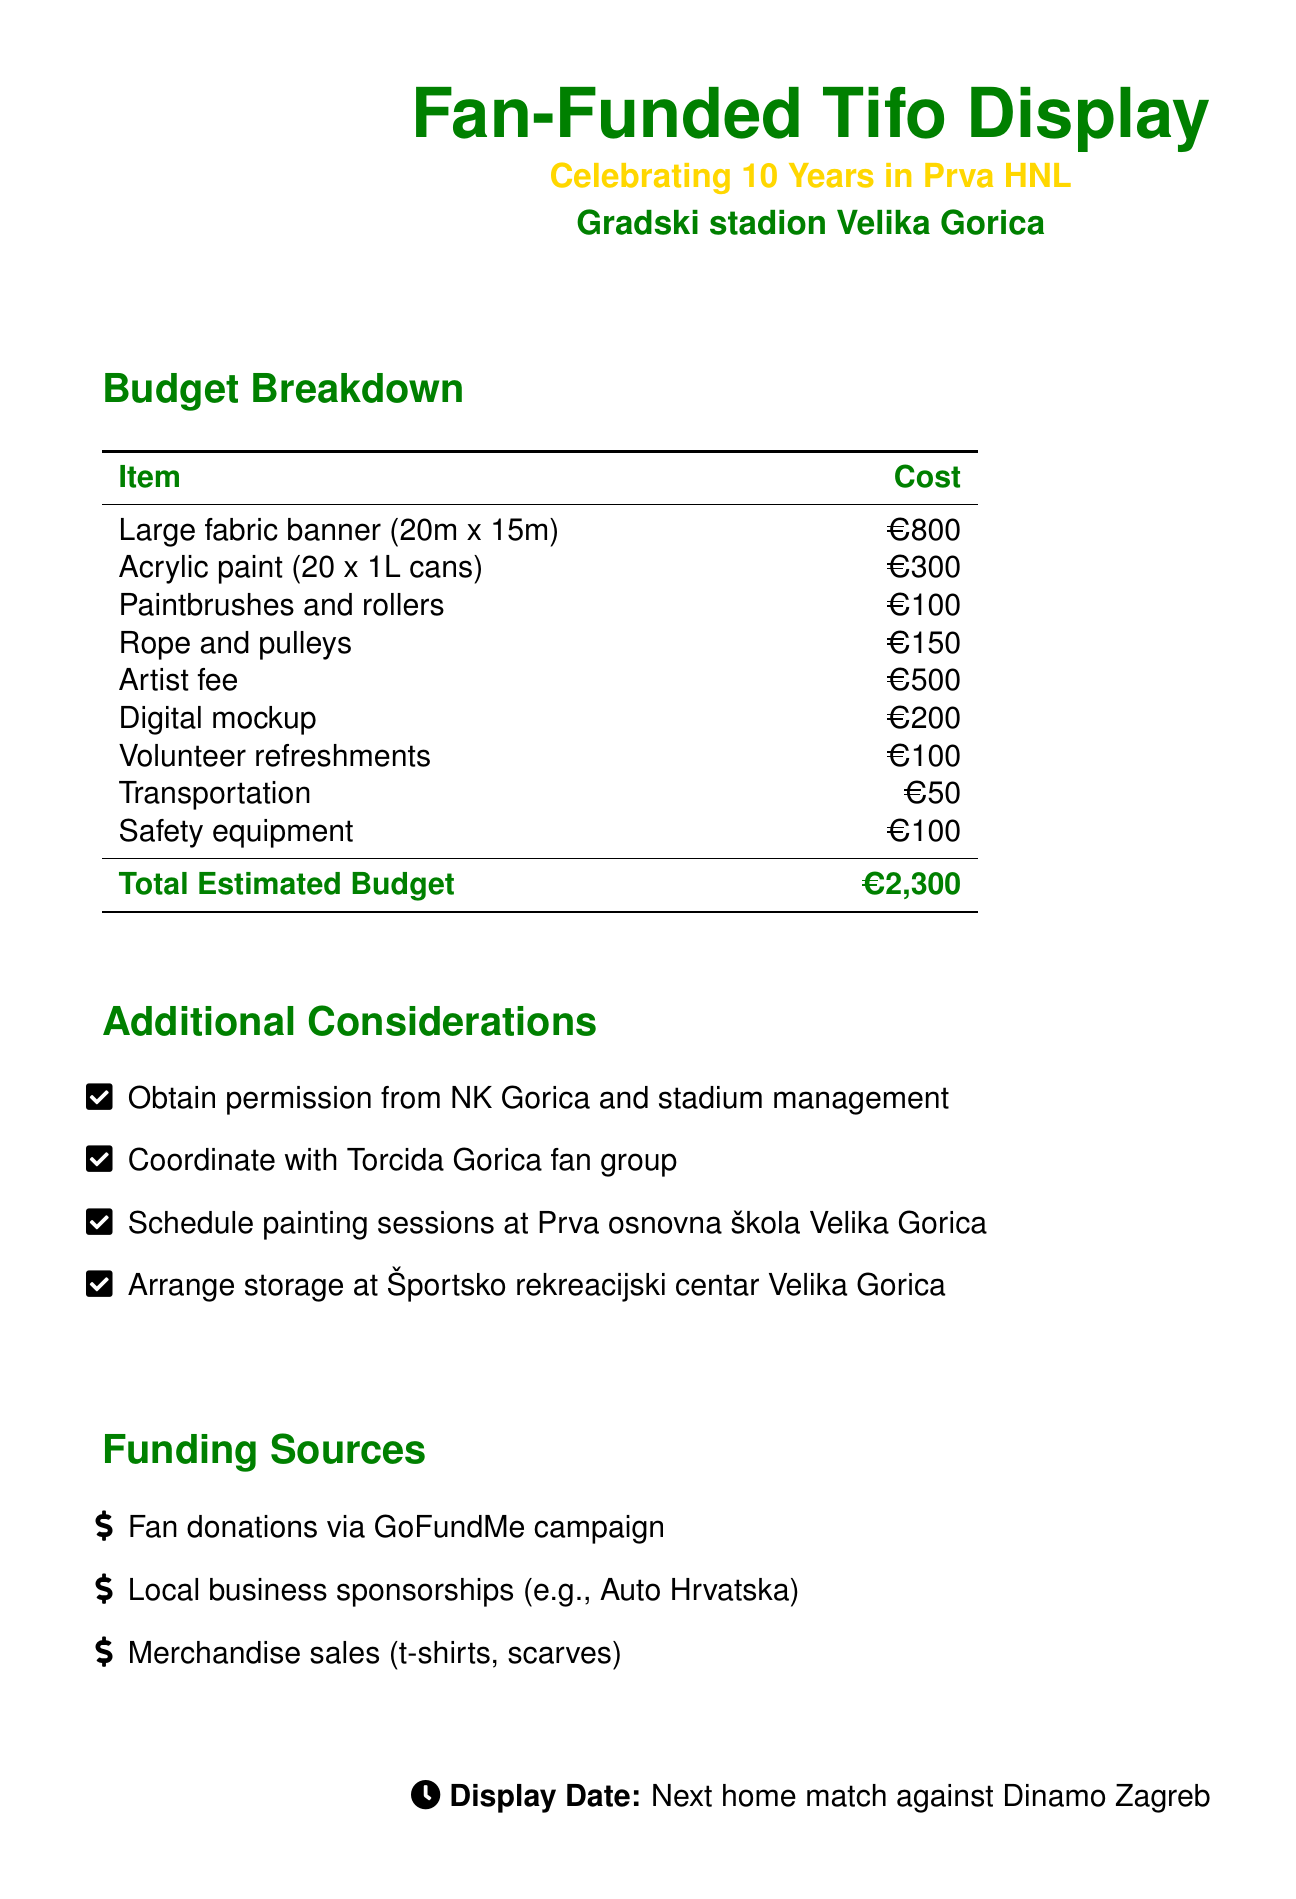What is the total estimated budget? The total estimated budget is provided at the end of the budget breakdown section.
Answer: €2,300 How much does the large fabric banner cost? The cost of the large fabric banner is listed in the budget breakdown table.
Answer: €800 What funding source involves fan donations? The document specifies that fan donations are collected through a crowdfunding campaign.
Answer: GoFundMe campaign What item has a cost of €500? This is found in the budget breakdown under artist fee.
Answer: Artist fee What materials are included for paint? The materials related to paint are specified in the budget table as the type and amount.
Answer: Acrylic paint What is the display date? The display date is mentioned at the bottom of the document, indicating when the event will occur.
Answer: Next home match against Dinamo Zagreb What type of event is being organized? The title at the beginning of the document gives context about the event being organized.
Answer: Fan-Funded Tifo Display What type of paint container is included in the budget? The budget specifies the quantity and type of paint container in the materials section.
Answer: 1L cans 